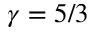<formula> <loc_0><loc_0><loc_500><loc_500>\gamma = 5 / 3</formula> 